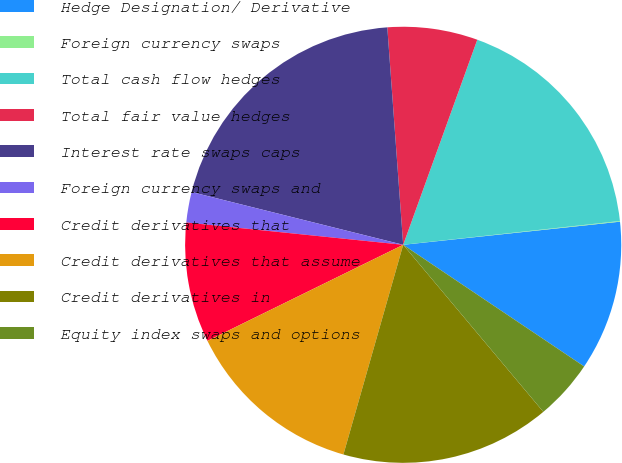Convert chart. <chart><loc_0><loc_0><loc_500><loc_500><pie_chart><fcel>Hedge Designation/ Derivative<fcel>Foreign currency swaps<fcel>Total cash flow hedges<fcel>Total fair value hedges<fcel>Interest rate swaps caps<fcel>Foreign currency swaps and<fcel>Credit derivatives that<fcel>Credit derivatives that assume<fcel>Credit derivatives in<fcel>Equity index swaps and options<nl><fcel>11.11%<fcel>0.05%<fcel>17.74%<fcel>6.68%<fcel>19.95%<fcel>2.26%<fcel>8.89%<fcel>13.32%<fcel>15.53%<fcel>4.47%<nl></chart> 